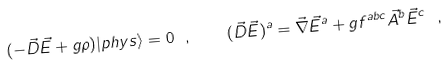<formula> <loc_0><loc_0><loc_500><loc_500>( - \vec { D } \vec { E } + g \rho ) | p h y s \rangle = 0 \ , \quad ( \vec { D } \vec { E } ) ^ { a } = \vec { \nabla } \vec { E } ^ { a } + g f ^ { a b c } \vec { A } ^ { b } \vec { E } ^ { c } \ ,</formula> 